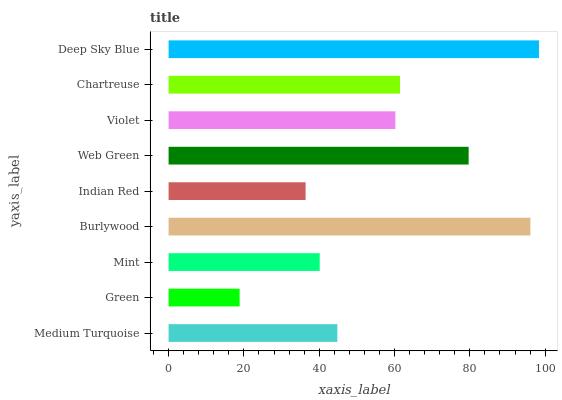Is Green the minimum?
Answer yes or no. Yes. Is Deep Sky Blue the maximum?
Answer yes or no. Yes. Is Mint the minimum?
Answer yes or no. No. Is Mint the maximum?
Answer yes or no. No. Is Mint greater than Green?
Answer yes or no. Yes. Is Green less than Mint?
Answer yes or no. Yes. Is Green greater than Mint?
Answer yes or no. No. Is Mint less than Green?
Answer yes or no. No. Is Violet the high median?
Answer yes or no. Yes. Is Violet the low median?
Answer yes or no. Yes. Is Green the high median?
Answer yes or no. No. Is Medium Turquoise the low median?
Answer yes or no. No. 